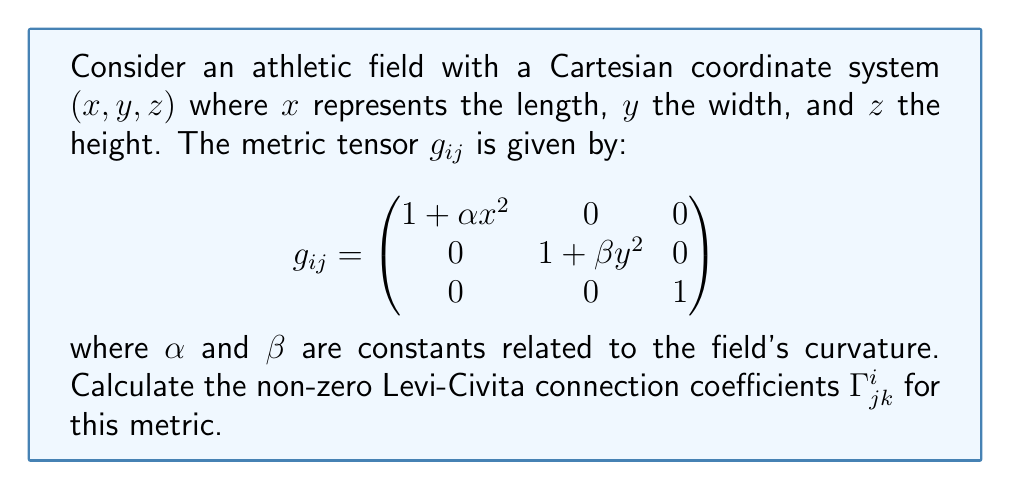Solve this math problem. To solve for the Levi-Civita connection coefficients, we'll use the formula:

$$\Gamma^i_{jk} = \frac{1}{2}g^{im}(\partial_j g_{km} + \partial_k g_{jm} - \partial_m g_{jk})$$

Where $g^{im}$ is the inverse of the metric tensor.

Step 1: Calculate the inverse metric tensor $g^{ij}$:
$$g^{ij} = \begin{pmatrix}
\frac{1}{1 + \alpha x^2} & 0 & 0 \\
0 & \frac{1}{1 + \beta y^2} & 0 \\
0 & 0 & 1
\end{pmatrix}$$

Step 2: Calculate the partial derivatives of the metric tensor:
$\partial_x g_{11} = 2\alpha x$
$\partial_y g_{22} = 2\beta y$
All other partial derivatives are zero.

Step 3: Apply the formula for each non-zero component:

For $\Gamma^1_{11}$:
$$\Gamma^1_{11} = \frac{1}{2}g^{11}(\partial_1 g_{11}) = \frac{1}{2}\frac{1}{1 + \alpha x^2}(2\alpha x) = \frac{\alpha x}{1 + \alpha x^2}$$

For $\Gamma^2_{22}$:
$$\Gamma^2_{22} = \frac{1}{2}g^{22}(\partial_2 g_{22}) = \frac{1}{2}\frac{1}{1 + \beta y^2}(2\beta y) = \frac{\beta y}{1 + \beta y^2}$$

All other components are zero due to the diagonal nature of the metric and its derivatives.
Answer: $\Gamma^1_{11} = \frac{\alpha x}{1 + \alpha x^2}$, $\Gamma^2_{22} = \frac{\beta y}{1 + \beta y^2}$, all others zero. 